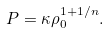<formula> <loc_0><loc_0><loc_500><loc_500>P = \kappa \rho _ { 0 } ^ { 1 + 1 / n } .</formula> 